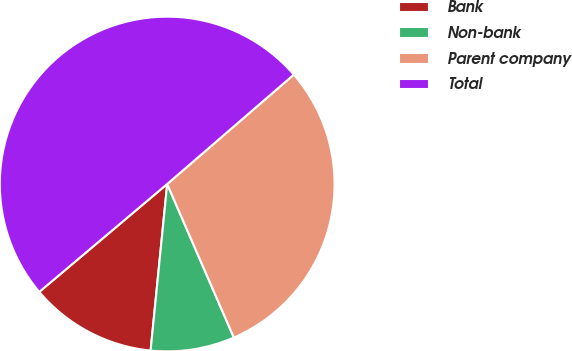Convert chart. <chart><loc_0><loc_0><loc_500><loc_500><pie_chart><fcel>Bank<fcel>Non-bank<fcel>Parent company<fcel>Total<nl><fcel>12.27%<fcel>8.1%<fcel>29.82%<fcel>49.81%<nl></chart> 